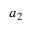<formula> <loc_0><loc_0><loc_500><loc_500>a _ { 2 }</formula> 